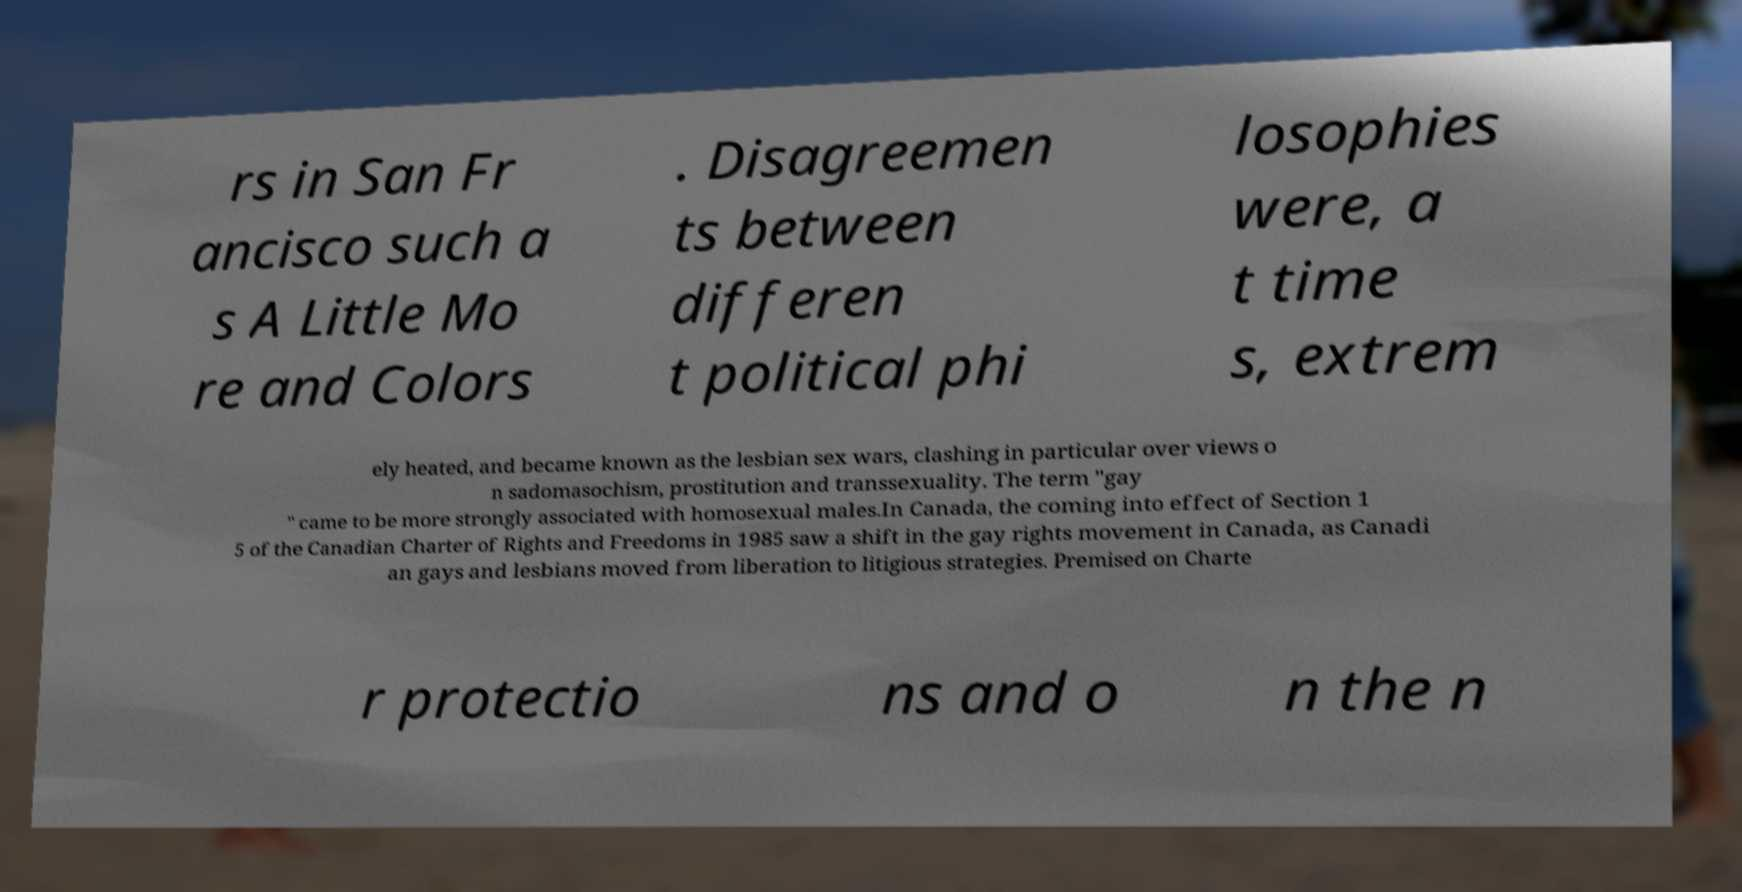What messages or text are displayed in this image? I need them in a readable, typed format. rs in San Fr ancisco such a s A Little Mo re and Colors . Disagreemen ts between differen t political phi losophies were, a t time s, extrem ely heated, and became known as the lesbian sex wars, clashing in particular over views o n sadomasochism, prostitution and transsexuality. The term "gay " came to be more strongly associated with homosexual males.In Canada, the coming into effect of Section 1 5 of the Canadian Charter of Rights and Freedoms in 1985 saw a shift in the gay rights movement in Canada, as Canadi an gays and lesbians moved from liberation to litigious strategies. Premised on Charte r protectio ns and o n the n 